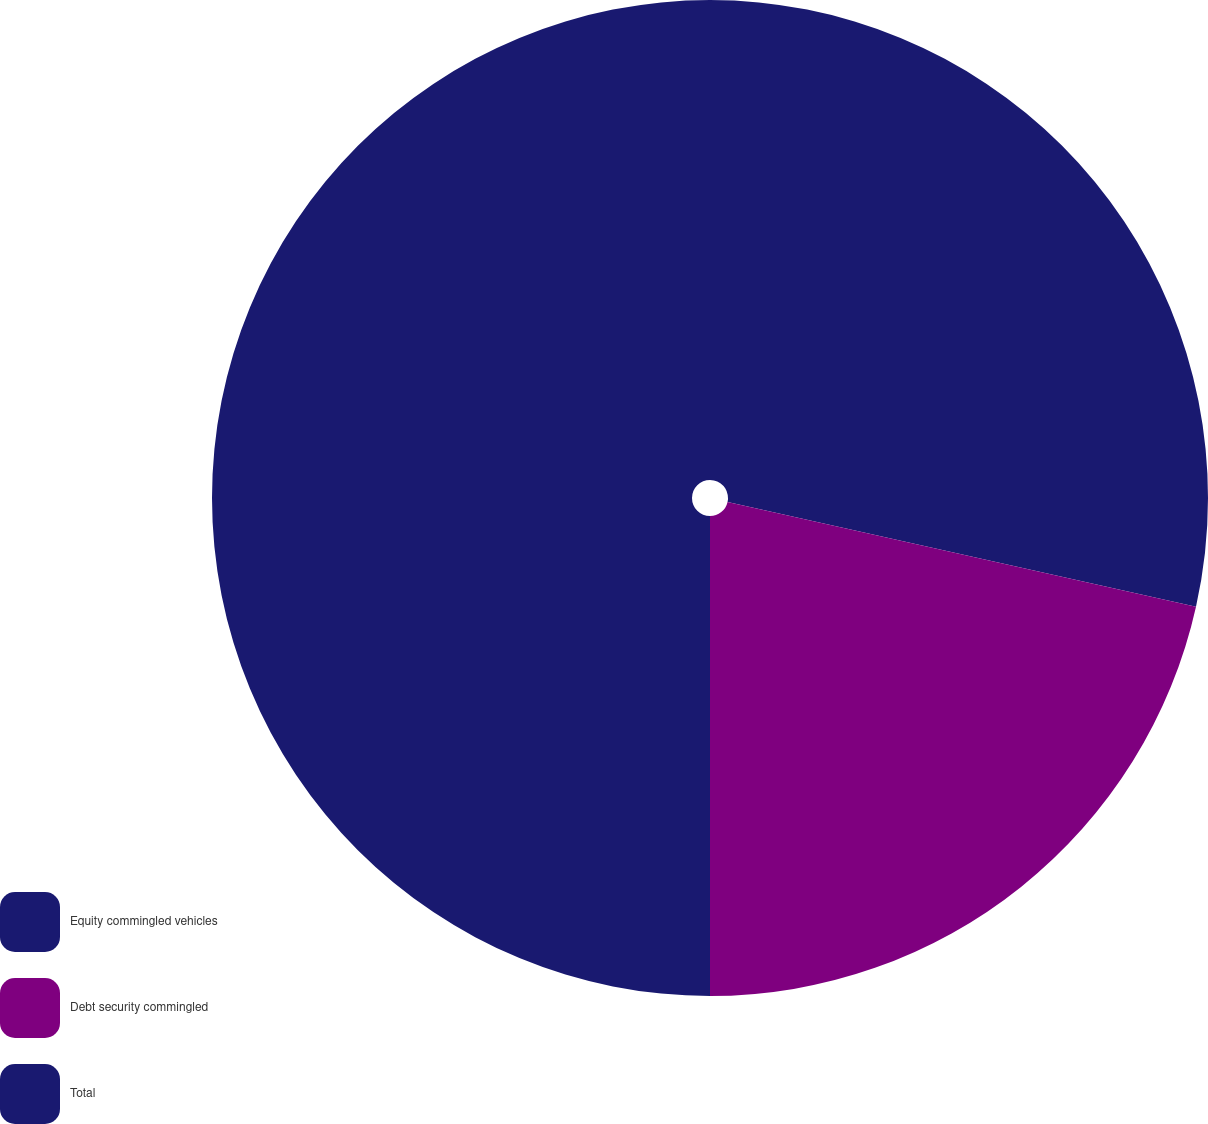<chart> <loc_0><loc_0><loc_500><loc_500><pie_chart><fcel>Equity commingled vehicles<fcel>Debt security commingled<fcel>Total<nl><fcel>28.5%<fcel>21.5%<fcel>50.0%<nl></chart> 